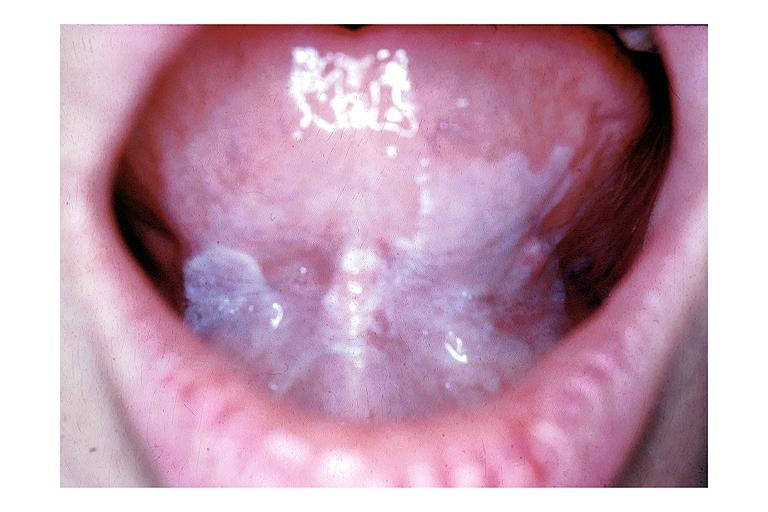where is this?
Answer the question using a single word or phrase. Oral 